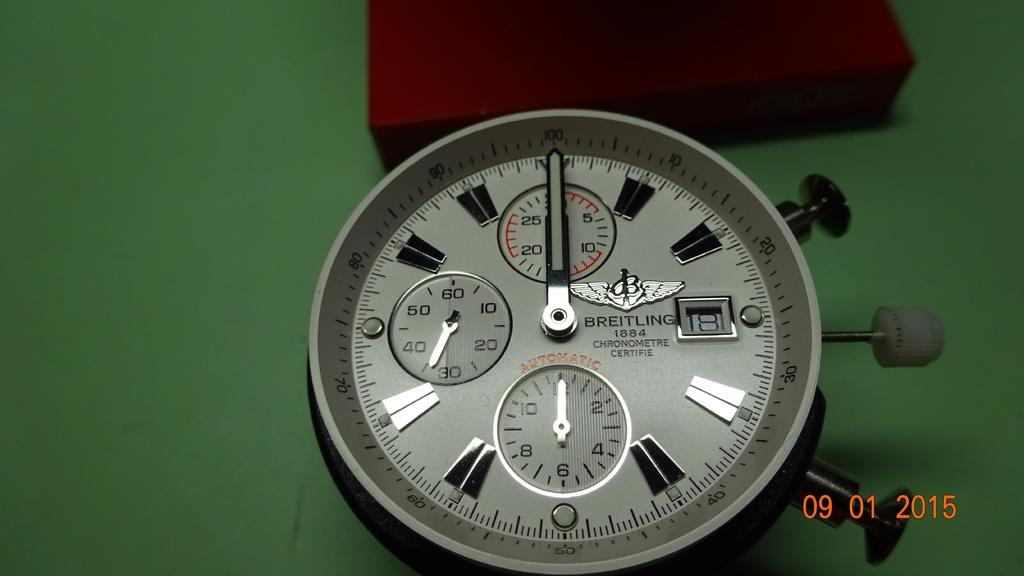<image>
Present a compact description of the photo's key features. A watch is branded Breitling 1884 and features an automatic chronometre. 